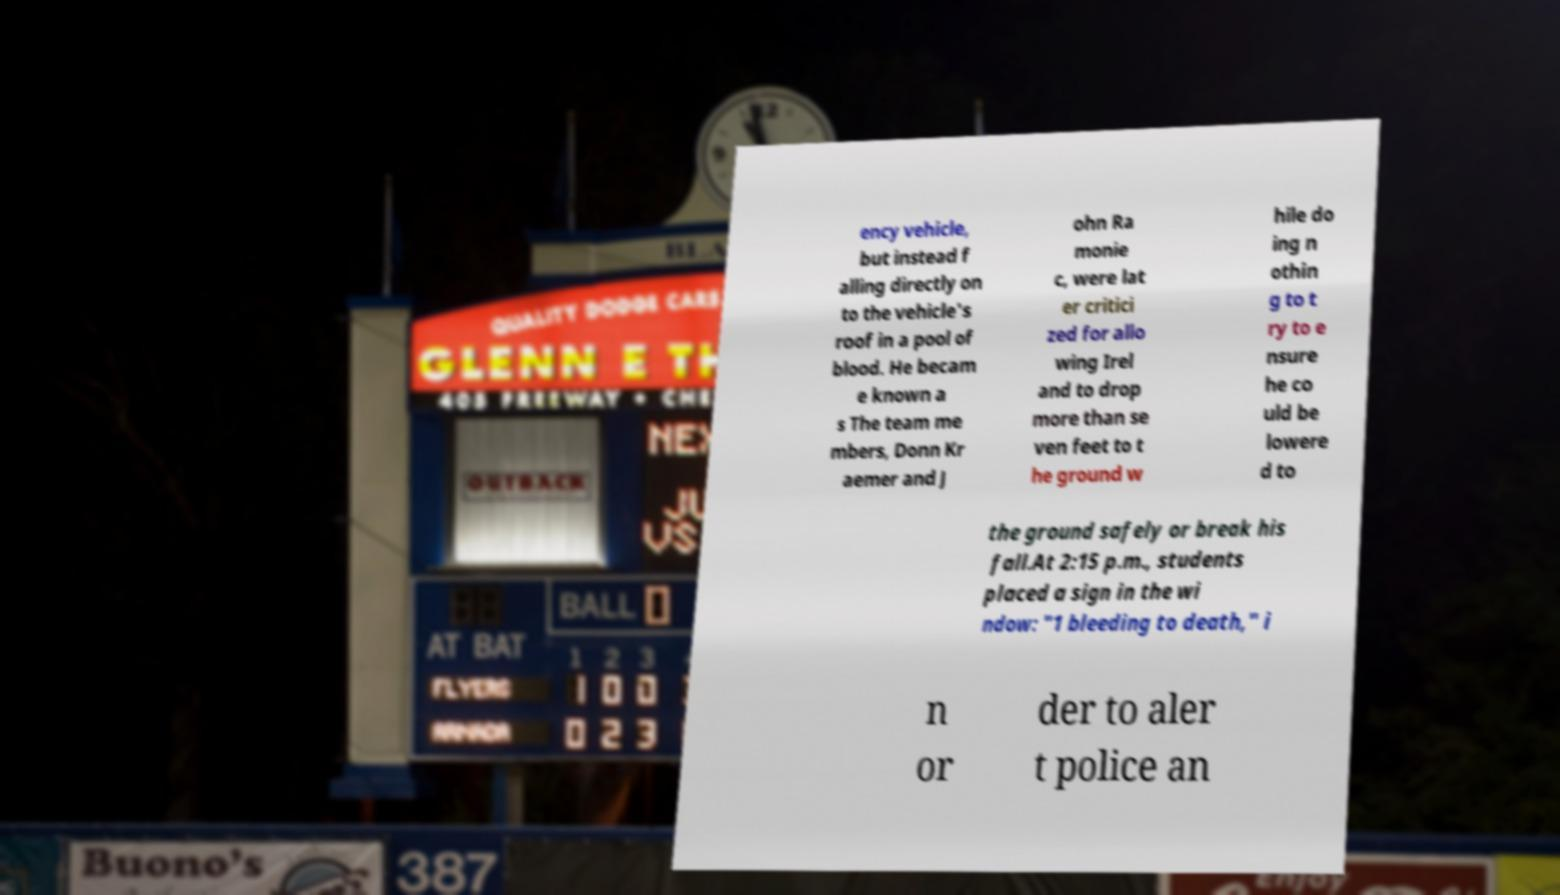Could you extract and type out the text from this image? ency vehicle, but instead f alling directly on to the vehicle's roof in a pool of blood. He becam e known a s The team me mbers, Donn Kr aemer and J ohn Ra monie c, were lat er critici zed for allo wing Irel and to drop more than se ven feet to t he ground w hile do ing n othin g to t ry to e nsure he co uld be lowere d to the ground safely or break his fall.At 2:15 p.m., students placed a sign in the wi ndow: "1 bleeding to death," i n or der to aler t police an 